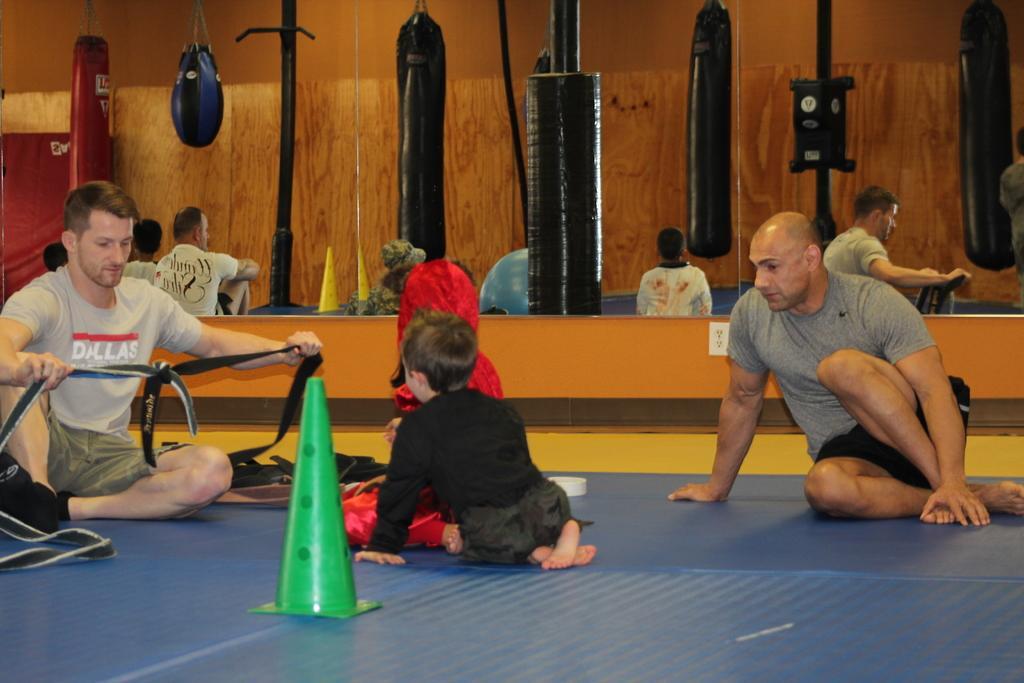Please provide a concise description of this image. In this picture there are some people sitting on the floor. I can observe two children on the floor. Beside them there is a green color traffic cone. There are some sandbags hanged to the ceiling. In the background there is a brown color wall. 